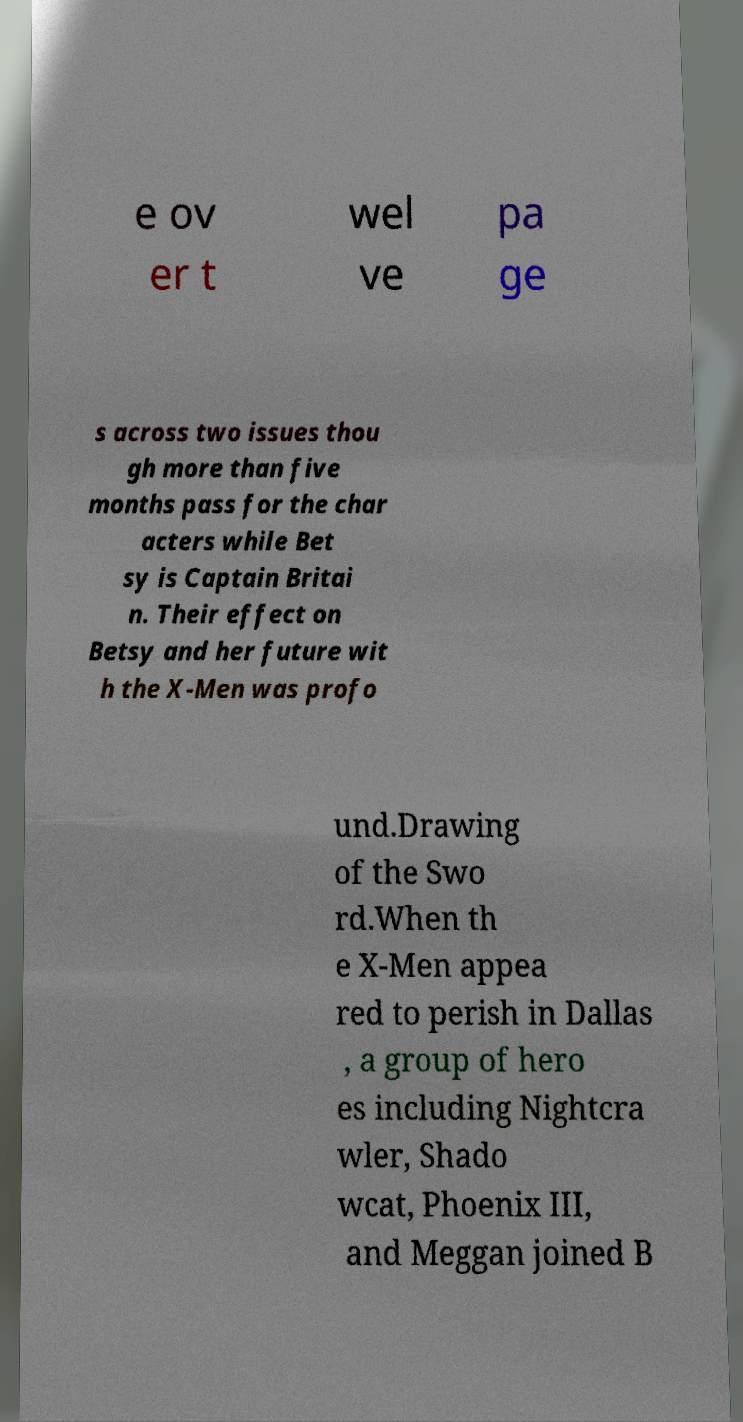Could you extract and type out the text from this image? e ov er t wel ve pa ge s across two issues thou gh more than five months pass for the char acters while Bet sy is Captain Britai n. Their effect on Betsy and her future wit h the X-Men was profo und.Drawing of the Swo rd.When th e X-Men appea red to perish in Dallas , a group of hero es including Nightcra wler, Shado wcat, Phoenix III, and Meggan joined B 